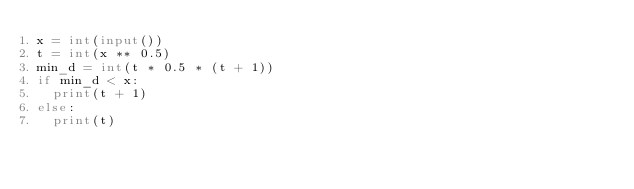<code> <loc_0><loc_0><loc_500><loc_500><_Python_>x = int(input())
t = int(x ** 0.5)
min_d = int(t * 0.5 * (t + 1))
if min_d < x:
  print(t + 1)
else:
  print(t)
</code> 